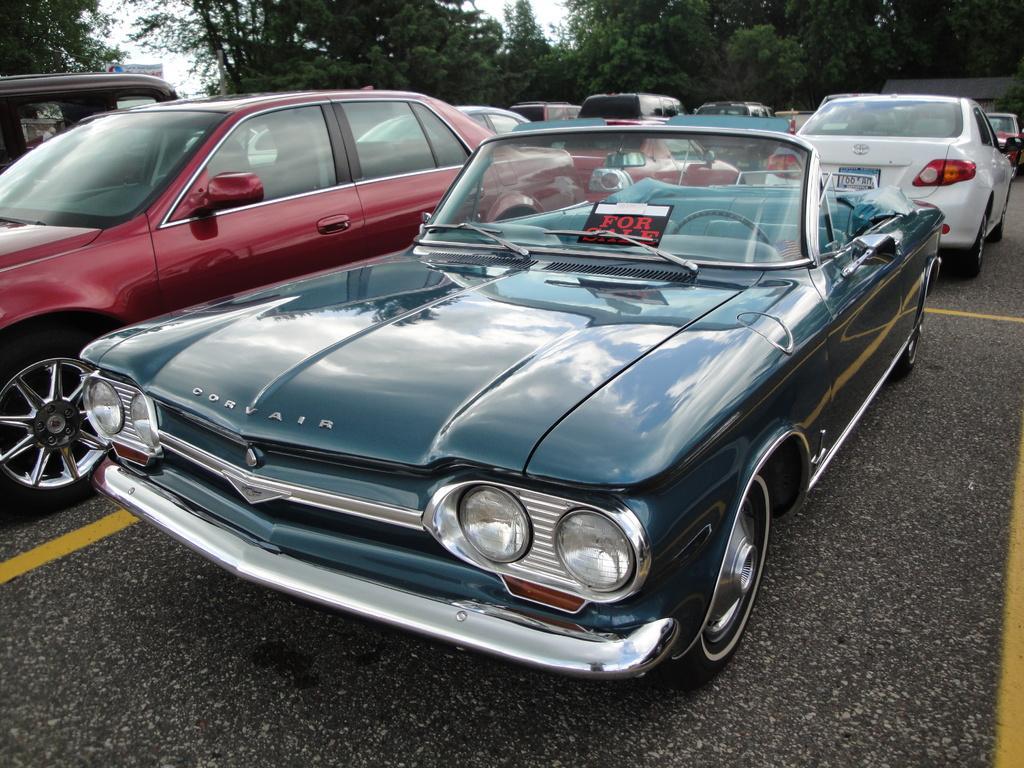In one or two sentences, can you explain what this image depicts? In this image we can see so many cars on the road. At the top of the image, we can see the sky and trees. 